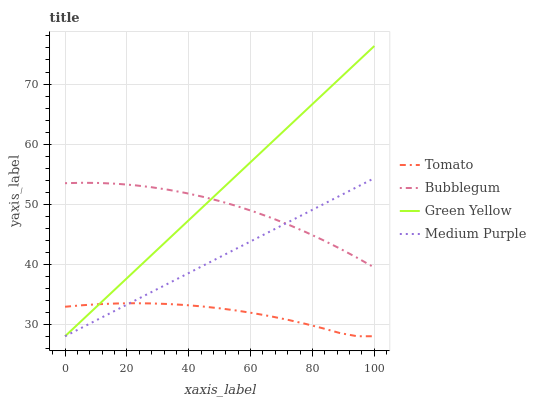Does Tomato have the minimum area under the curve?
Answer yes or no. Yes. Does Green Yellow have the maximum area under the curve?
Answer yes or no. Yes. Does Medium Purple have the minimum area under the curve?
Answer yes or no. No. Does Medium Purple have the maximum area under the curve?
Answer yes or no. No. Is Medium Purple the smoothest?
Answer yes or no. Yes. Is Tomato the roughest?
Answer yes or no. Yes. Is Green Yellow the smoothest?
Answer yes or no. No. Is Green Yellow the roughest?
Answer yes or no. No. Does Tomato have the lowest value?
Answer yes or no. Yes. Does Bubblegum have the lowest value?
Answer yes or no. No. Does Green Yellow have the highest value?
Answer yes or no. Yes. Does Medium Purple have the highest value?
Answer yes or no. No. Is Tomato less than Bubblegum?
Answer yes or no. Yes. Is Bubblegum greater than Tomato?
Answer yes or no. Yes. Does Green Yellow intersect Medium Purple?
Answer yes or no. Yes. Is Green Yellow less than Medium Purple?
Answer yes or no. No. Is Green Yellow greater than Medium Purple?
Answer yes or no. No. Does Tomato intersect Bubblegum?
Answer yes or no. No. 